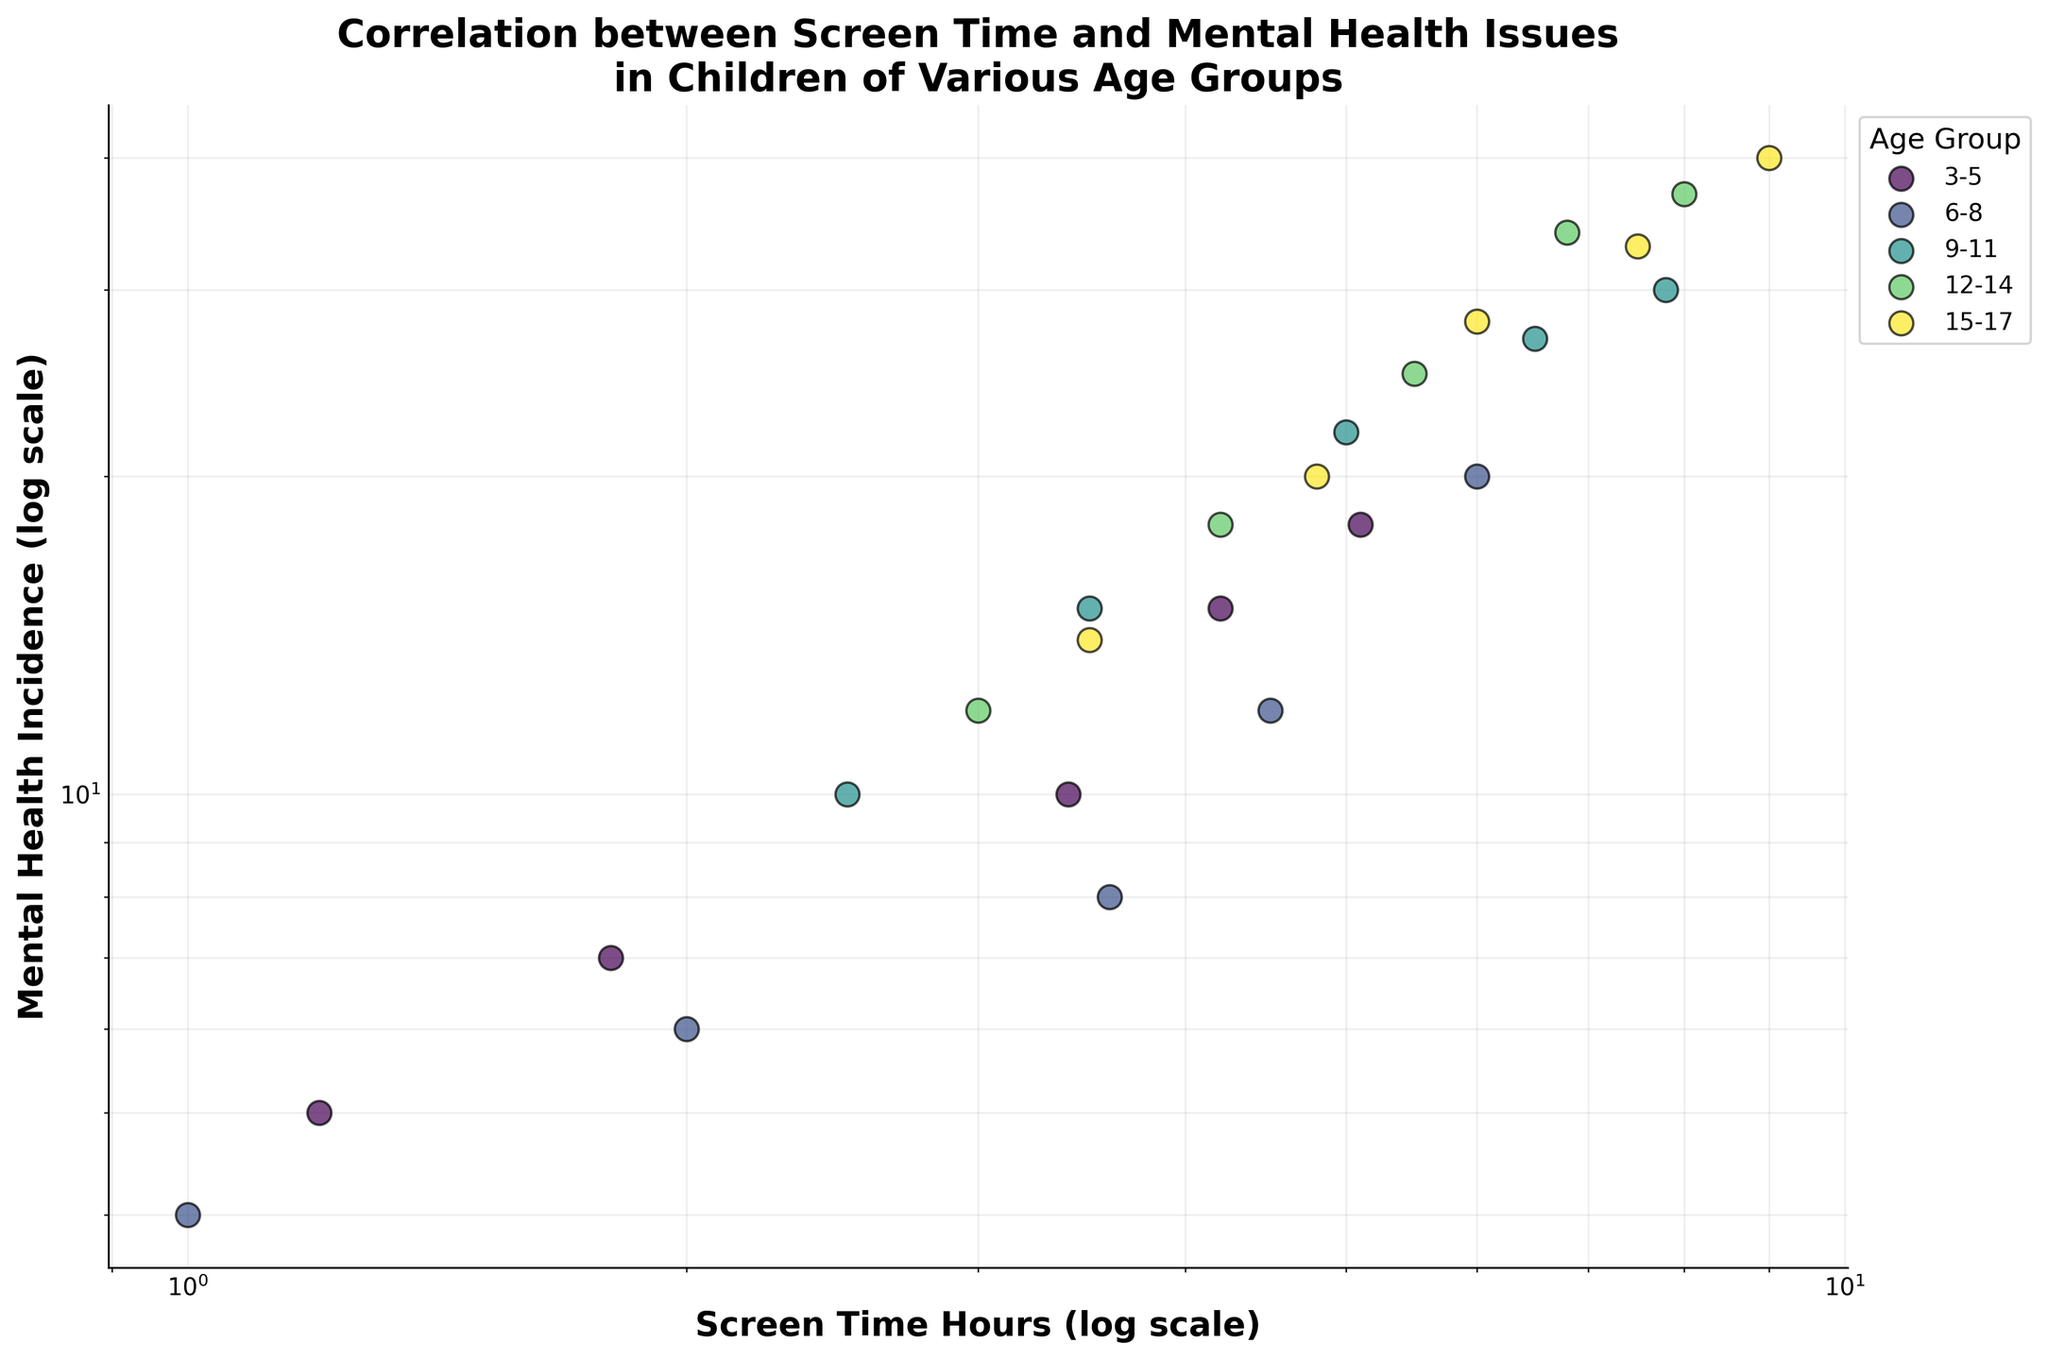What is the title of the figure? The title is located at the top of the figure and reads: "Correlation between Screen Time and Mental Health Issues in Children of Various Age Groups".
Answer: Correlation between Screen Time and Mental Health Issues in Children of Various Age Groups How many different age groups are represented in the figure? Each data series in the figure represents an age group. According to the colors and the legend, there are five age groups.
Answer: Five Which age group has the highest incidence of mental health issues at the highest screen time hour recorded? First, identify the highest screen time hour on the x-axis. The 15-17 age group has a point at 9.0 screen time hours with 40 mental health incidence.
Answer: 15-17 What is the range of screen time hours observed for the 6-8 age group? The 6-8 age group data points on the horizontal axis range from the smallest to the largest values. The smallest is 1.0 hours, and the largest is 6.0 hours.
Answer: 1.0 to 6.0 hours Compare the mental health incidence between the 3-5 and 15-17 age groups when screen time is around 4.2 hours. Which is higher? Find the points for both age groups near 4.2 screen time hours. The 3-5 age group has an incidence of 15, while the 15-17 age group incidence is 20. Thus, 15-17 is higher.
Answer: 15-17 age group For the 12-14 age group, what is the mental health incidence for the maximum screen time recorded? Identify the highest screen time for the 12-14 group and check the corresponding mental health incidence. At 8.0 screen time hours, the incidence is 37.
Answer: 37 Which age group shows the most significant increase in mental health incidence between 3.0 and 6.8 screen time hours? Calculate the difference in mental health incidence between the two screen times for each age group. The 12-14 age group goes from 12 (at 3.0 hours) to 34 (at 6.8 hours), an increase of 22, which is the most significant.
Answer: 12-14 On the log-log scale, how does the relationship between screen time and mental health incidence appear for most age groups? On a log-log plot, a linear relationship indicates a power-law correlation. Most age groups show an upward linear trend, meaning higher screen time is associated with higher mental health incidence.
Answer: Upward linear trend Are there any age groups that exhibit a non-linear relationship between screen time and mental health incidence? Though most show a linear relationship, if examining all groups closely, no distinct non-linear trends are evident among the data points on this plot.
Answer: No What is the general trend in mental health incidence as screen time increases across all age groups? Overall, regardless of the age group, as screen time increases, mental health incidence also increases. This upward trend is seen across all age groups.
Answer: Increases 